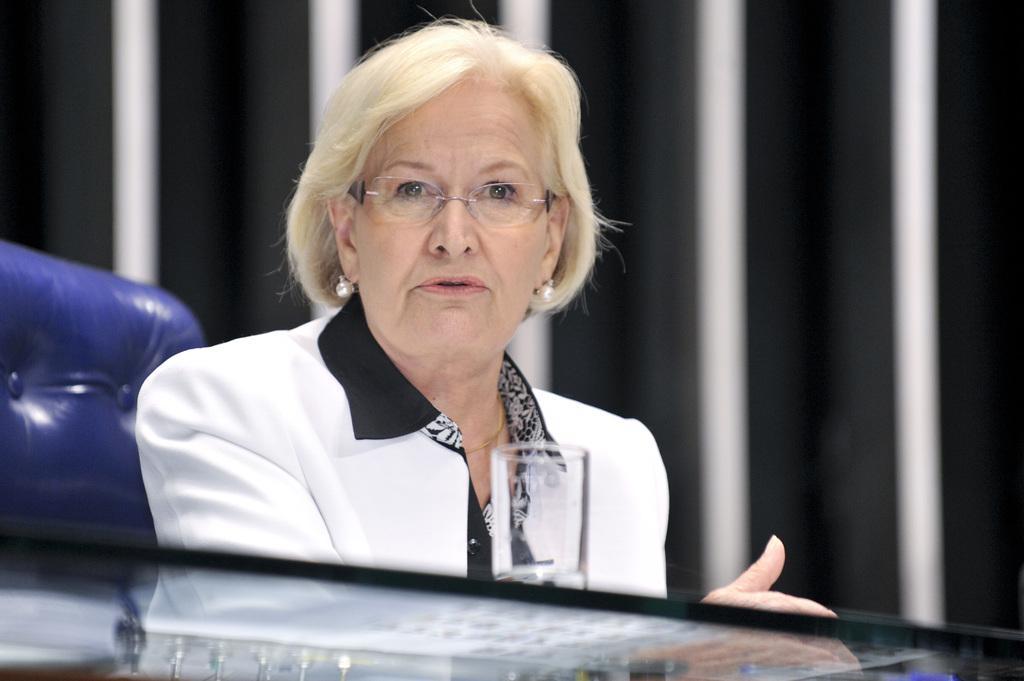Describe this image in one or two sentences. In this image we can see an old woman sitting on the chair. And we can see the glass table. And we can see the blurred background. 